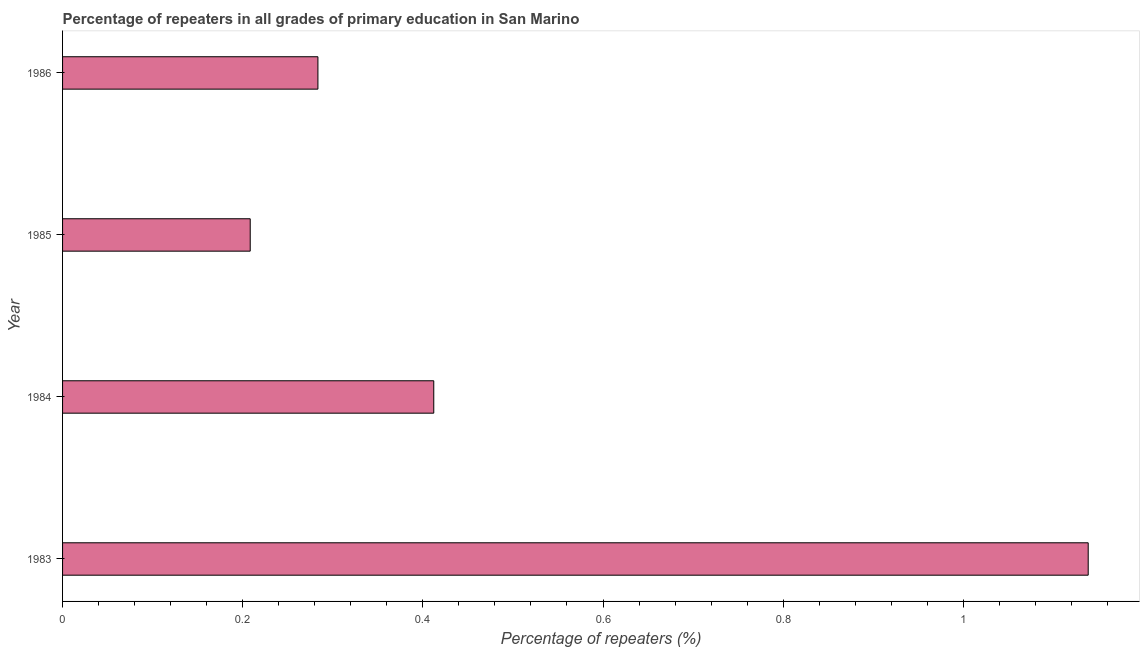Does the graph contain any zero values?
Make the answer very short. No. What is the title of the graph?
Your answer should be very brief. Percentage of repeaters in all grades of primary education in San Marino. What is the label or title of the X-axis?
Your answer should be very brief. Percentage of repeaters (%). What is the label or title of the Y-axis?
Ensure brevity in your answer.  Year. What is the percentage of repeaters in primary education in 1986?
Your response must be concise. 0.28. Across all years, what is the maximum percentage of repeaters in primary education?
Offer a terse response. 1.14. Across all years, what is the minimum percentage of repeaters in primary education?
Provide a succinct answer. 0.21. In which year was the percentage of repeaters in primary education maximum?
Provide a short and direct response. 1983. What is the sum of the percentage of repeaters in primary education?
Make the answer very short. 2.04. What is the difference between the percentage of repeaters in primary education in 1983 and 1986?
Offer a terse response. 0.85. What is the average percentage of repeaters in primary education per year?
Give a very brief answer. 0.51. What is the median percentage of repeaters in primary education?
Your response must be concise. 0.35. In how many years, is the percentage of repeaters in primary education greater than 0.84 %?
Your response must be concise. 1. Do a majority of the years between 1986 and 1983 (inclusive) have percentage of repeaters in primary education greater than 1.12 %?
Your answer should be very brief. Yes. What is the ratio of the percentage of repeaters in primary education in 1983 to that in 1984?
Keep it short and to the point. 2.76. Is the difference between the percentage of repeaters in primary education in 1983 and 1984 greater than the difference between any two years?
Offer a very short reply. No. What is the difference between the highest and the second highest percentage of repeaters in primary education?
Provide a succinct answer. 0.73. Is the sum of the percentage of repeaters in primary education in 1984 and 1986 greater than the maximum percentage of repeaters in primary education across all years?
Make the answer very short. No. What is the difference between the highest and the lowest percentage of repeaters in primary education?
Make the answer very short. 0.93. Are all the bars in the graph horizontal?
Give a very brief answer. Yes. Are the values on the major ticks of X-axis written in scientific E-notation?
Provide a succinct answer. No. What is the Percentage of repeaters (%) in 1983?
Make the answer very short. 1.14. What is the Percentage of repeaters (%) of 1984?
Offer a very short reply. 0.41. What is the Percentage of repeaters (%) of 1985?
Give a very brief answer. 0.21. What is the Percentage of repeaters (%) in 1986?
Your response must be concise. 0.28. What is the difference between the Percentage of repeaters (%) in 1983 and 1984?
Provide a short and direct response. 0.73. What is the difference between the Percentage of repeaters (%) in 1983 and 1985?
Your response must be concise. 0.93. What is the difference between the Percentage of repeaters (%) in 1983 and 1986?
Keep it short and to the point. 0.86. What is the difference between the Percentage of repeaters (%) in 1984 and 1985?
Provide a short and direct response. 0.2. What is the difference between the Percentage of repeaters (%) in 1984 and 1986?
Provide a succinct answer. 0.13. What is the difference between the Percentage of repeaters (%) in 1985 and 1986?
Offer a very short reply. -0.08. What is the ratio of the Percentage of repeaters (%) in 1983 to that in 1984?
Your answer should be very brief. 2.76. What is the ratio of the Percentage of repeaters (%) in 1983 to that in 1985?
Give a very brief answer. 5.47. What is the ratio of the Percentage of repeaters (%) in 1983 to that in 1986?
Your answer should be compact. 4.02. What is the ratio of the Percentage of repeaters (%) in 1984 to that in 1985?
Offer a terse response. 1.98. What is the ratio of the Percentage of repeaters (%) in 1984 to that in 1986?
Your answer should be very brief. 1.45. What is the ratio of the Percentage of repeaters (%) in 1985 to that in 1986?
Your answer should be very brief. 0.73. 